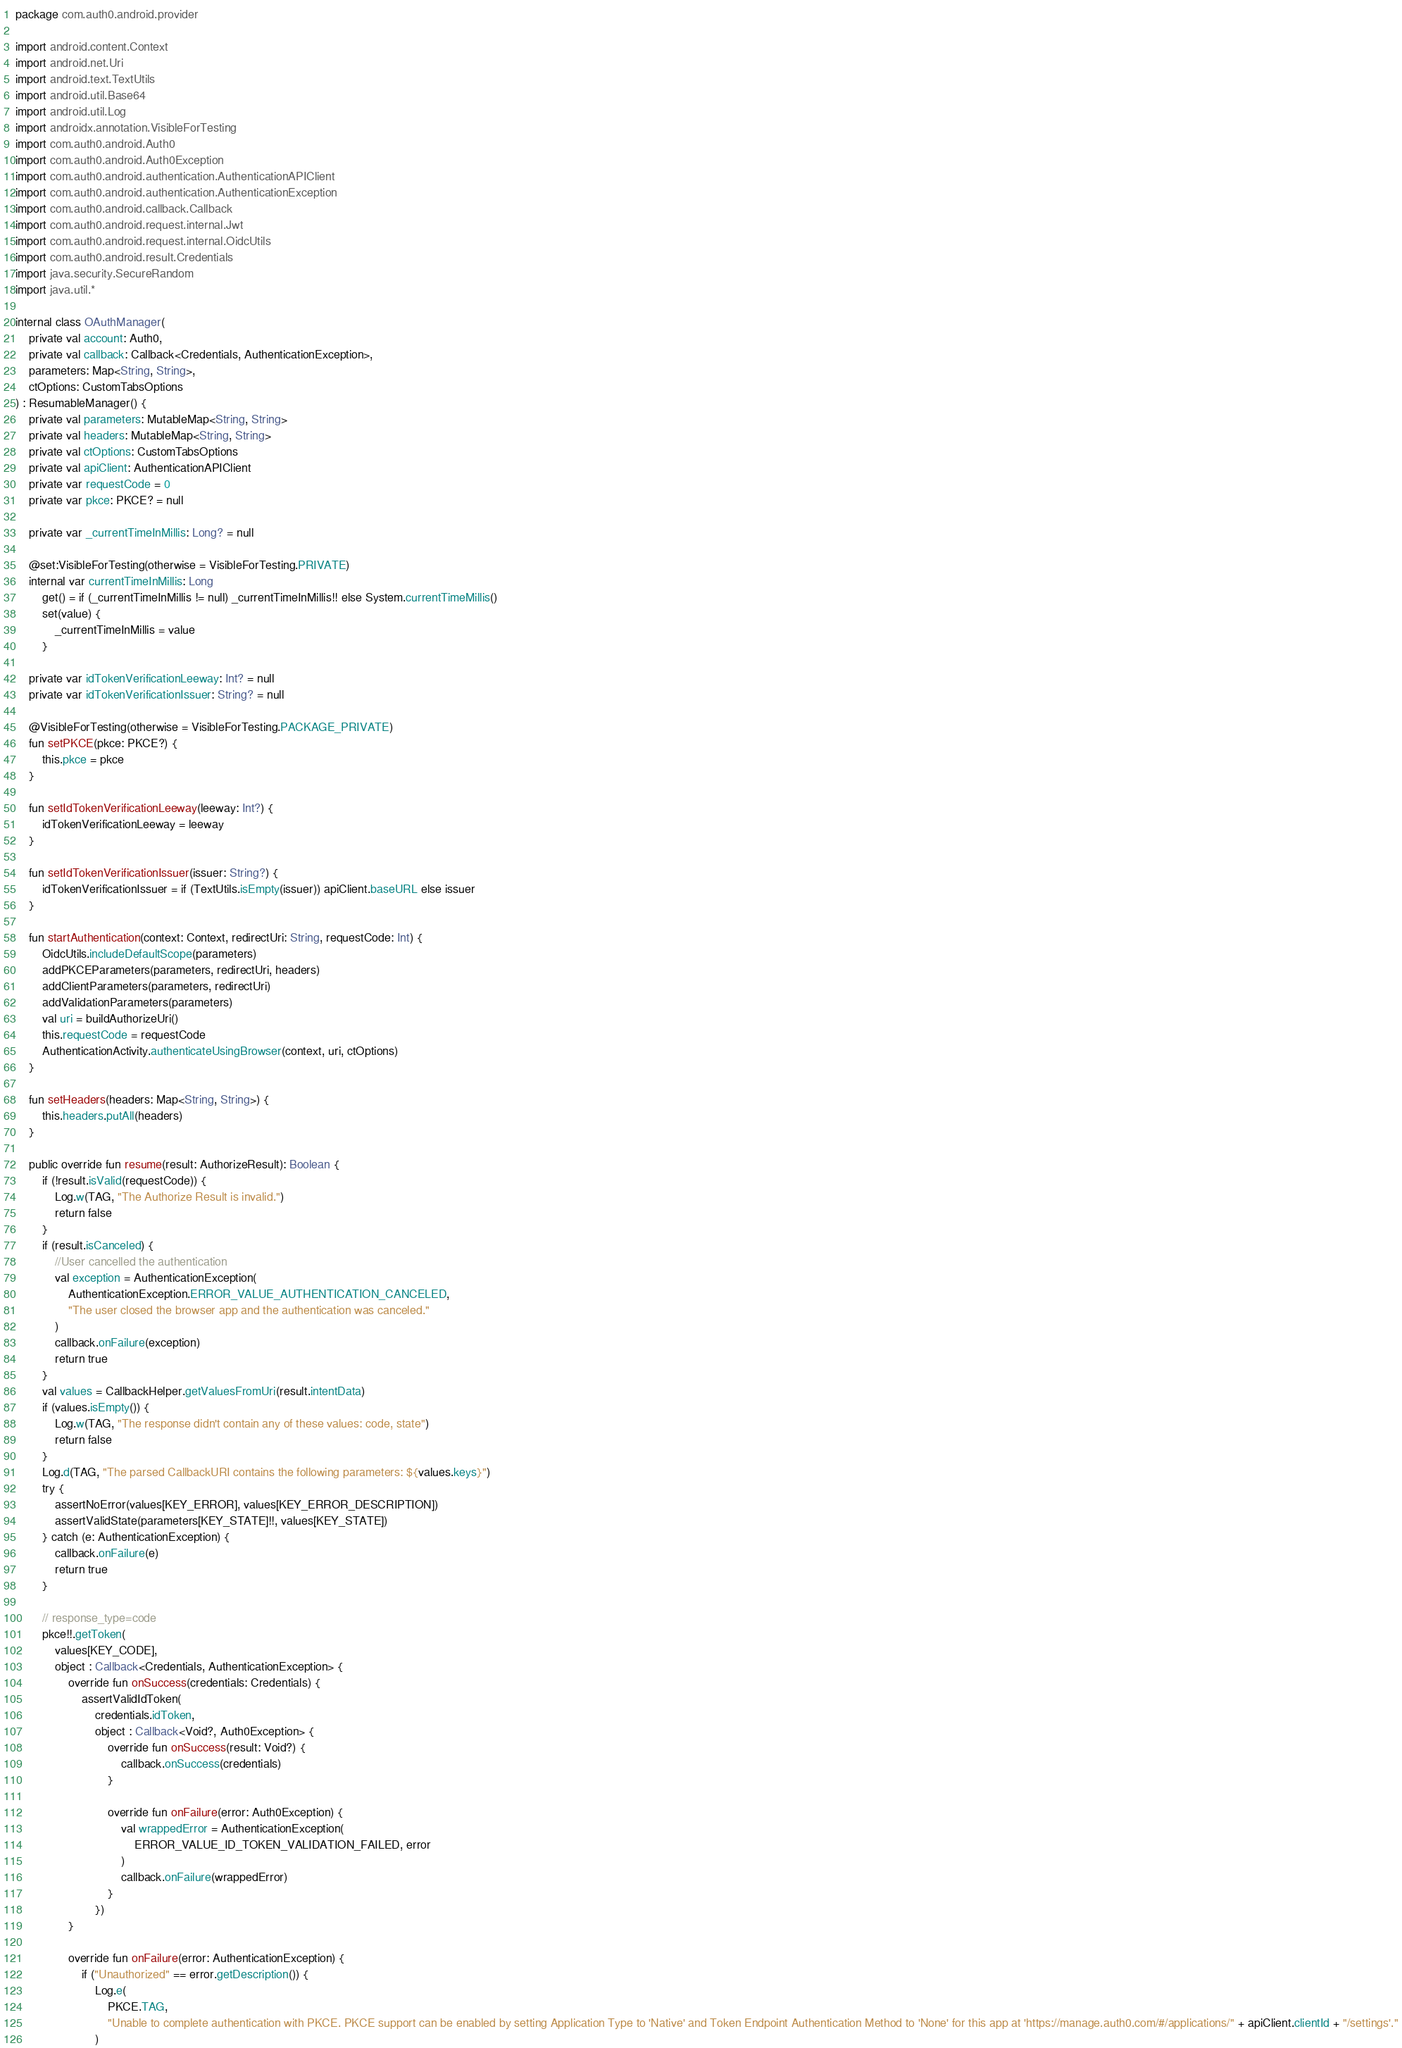Convert code to text. <code><loc_0><loc_0><loc_500><loc_500><_Kotlin_>package com.auth0.android.provider

import android.content.Context
import android.net.Uri
import android.text.TextUtils
import android.util.Base64
import android.util.Log
import androidx.annotation.VisibleForTesting
import com.auth0.android.Auth0
import com.auth0.android.Auth0Exception
import com.auth0.android.authentication.AuthenticationAPIClient
import com.auth0.android.authentication.AuthenticationException
import com.auth0.android.callback.Callback
import com.auth0.android.request.internal.Jwt
import com.auth0.android.request.internal.OidcUtils
import com.auth0.android.result.Credentials
import java.security.SecureRandom
import java.util.*

internal class OAuthManager(
    private val account: Auth0,
    private val callback: Callback<Credentials, AuthenticationException>,
    parameters: Map<String, String>,
    ctOptions: CustomTabsOptions
) : ResumableManager() {
    private val parameters: MutableMap<String, String>
    private val headers: MutableMap<String, String>
    private val ctOptions: CustomTabsOptions
    private val apiClient: AuthenticationAPIClient
    private var requestCode = 0
    private var pkce: PKCE? = null

    private var _currentTimeInMillis: Long? = null

    @set:VisibleForTesting(otherwise = VisibleForTesting.PRIVATE)
    internal var currentTimeInMillis: Long
        get() = if (_currentTimeInMillis != null) _currentTimeInMillis!! else System.currentTimeMillis()
        set(value) {
            _currentTimeInMillis = value
        }

    private var idTokenVerificationLeeway: Int? = null
    private var idTokenVerificationIssuer: String? = null

    @VisibleForTesting(otherwise = VisibleForTesting.PACKAGE_PRIVATE)
    fun setPKCE(pkce: PKCE?) {
        this.pkce = pkce
    }

    fun setIdTokenVerificationLeeway(leeway: Int?) {
        idTokenVerificationLeeway = leeway
    }

    fun setIdTokenVerificationIssuer(issuer: String?) {
        idTokenVerificationIssuer = if (TextUtils.isEmpty(issuer)) apiClient.baseURL else issuer
    }

    fun startAuthentication(context: Context, redirectUri: String, requestCode: Int) {
        OidcUtils.includeDefaultScope(parameters)
        addPKCEParameters(parameters, redirectUri, headers)
        addClientParameters(parameters, redirectUri)
        addValidationParameters(parameters)
        val uri = buildAuthorizeUri()
        this.requestCode = requestCode
        AuthenticationActivity.authenticateUsingBrowser(context, uri, ctOptions)
    }

    fun setHeaders(headers: Map<String, String>) {
        this.headers.putAll(headers)
    }

    public override fun resume(result: AuthorizeResult): Boolean {
        if (!result.isValid(requestCode)) {
            Log.w(TAG, "The Authorize Result is invalid.")
            return false
        }
        if (result.isCanceled) {
            //User cancelled the authentication
            val exception = AuthenticationException(
                AuthenticationException.ERROR_VALUE_AUTHENTICATION_CANCELED,
                "The user closed the browser app and the authentication was canceled."
            )
            callback.onFailure(exception)
            return true
        }
        val values = CallbackHelper.getValuesFromUri(result.intentData)
        if (values.isEmpty()) {
            Log.w(TAG, "The response didn't contain any of these values: code, state")
            return false
        }
        Log.d(TAG, "The parsed CallbackURI contains the following parameters: ${values.keys}")
        try {
            assertNoError(values[KEY_ERROR], values[KEY_ERROR_DESCRIPTION])
            assertValidState(parameters[KEY_STATE]!!, values[KEY_STATE])
        } catch (e: AuthenticationException) {
            callback.onFailure(e)
            return true
        }

        // response_type=code
        pkce!!.getToken(
            values[KEY_CODE],
            object : Callback<Credentials, AuthenticationException> {
                override fun onSuccess(credentials: Credentials) {
                    assertValidIdToken(
                        credentials.idToken,
                        object : Callback<Void?, Auth0Exception> {
                            override fun onSuccess(result: Void?) {
                                callback.onSuccess(credentials)
                            }

                            override fun onFailure(error: Auth0Exception) {
                                val wrappedError = AuthenticationException(
                                    ERROR_VALUE_ID_TOKEN_VALIDATION_FAILED, error
                                )
                                callback.onFailure(wrappedError)
                            }
                        })
                }

                override fun onFailure(error: AuthenticationException) {
                    if ("Unauthorized" == error.getDescription()) {
                        Log.e(
                            PKCE.TAG,
                            "Unable to complete authentication with PKCE. PKCE support can be enabled by setting Application Type to 'Native' and Token Endpoint Authentication Method to 'None' for this app at 'https://manage.auth0.com/#/applications/" + apiClient.clientId + "/settings'."
                        )</code> 